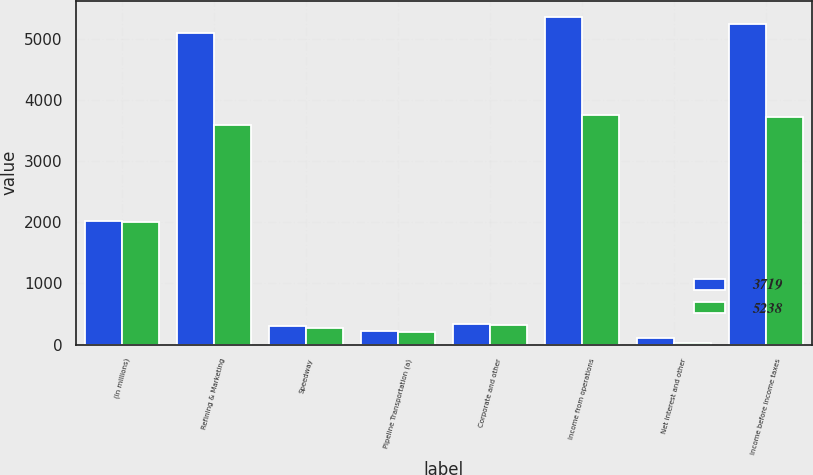Convert chart. <chart><loc_0><loc_0><loc_500><loc_500><stacked_bar_chart><ecel><fcel>(In millions)<fcel>Refining & Marketing<fcel>Speedway<fcel>Pipeline Transportation (a)<fcel>Corporate and other<fcel>Income from operations<fcel>Net interest and other<fcel>Income before income taxes<nl><fcel>3719<fcel>2012<fcel>5098<fcel>310<fcel>216<fcel>336<fcel>5347<fcel>109<fcel>5238<nl><fcel>5238<fcel>2011<fcel>3591<fcel>271<fcel>199<fcel>316<fcel>3745<fcel>26<fcel>3719<nl></chart> 